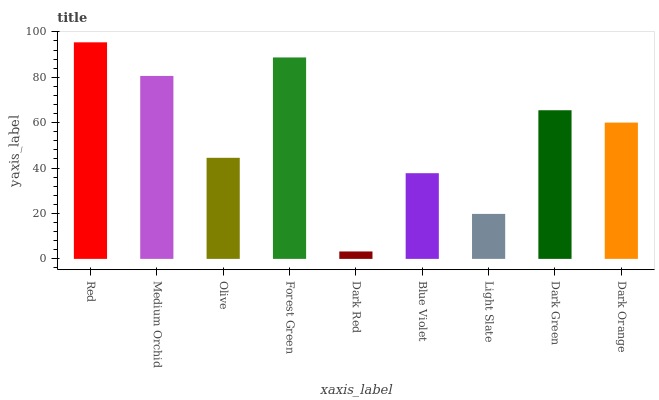Is Dark Red the minimum?
Answer yes or no. Yes. Is Red the maximum?
Answer yes or no. Yes. Is Medium Orchid the minimum?
Answer yes or no. No. Is Medium Orchid the maximum?
Answer yes or no. No. Is Red greater than Medium Orchid?
Answer yes or no. Yes. Is Medium Orchid less than Red?
Answer yes or no. Yes. Is Medium Orchid greater than Red?
Answer yes or no. No. Is Red less than Medium Orchid?
Answer yes or no. No. Is Dark Orange the high median?
Answer yes or no. Yes. Is Dark Orange the low median?
Answer yes or no. Yes. Is Red the high median?
Answer yes or no. No. Is Light Slate the low median?
Answer yes or no. No. 